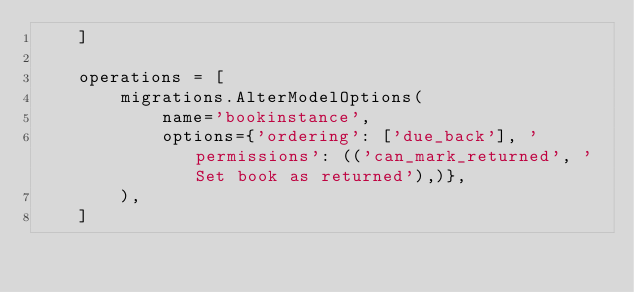Convert code to text. <code><loc_0><loc_0><loc_500><loc_500><_Python_>    ]

    operations = [
        migrations.AlterModelOptions(
            name='bookinstance',
            options={'ordering': ['due_back'], 'permissions': (('can_mark_returned', 'Set book as returned'),)},
        ),
    ]
</code> 